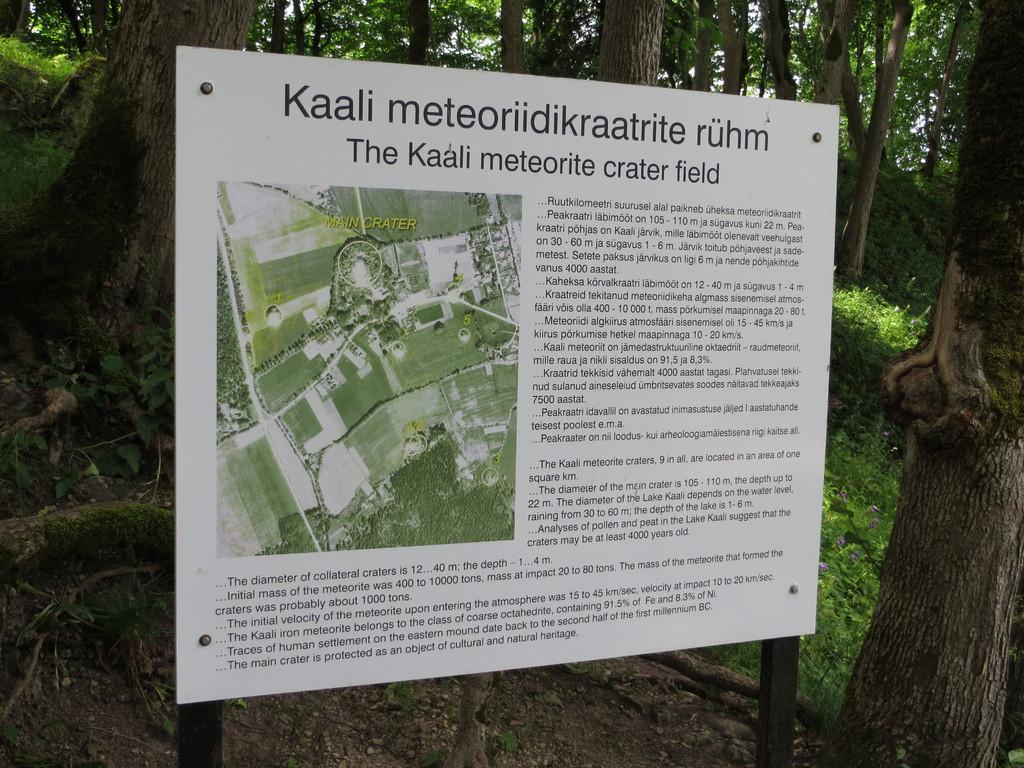Please provide a concise description of this image. In this image in the center there is one board, on the board there is text and an image of trees and some buildings. And in the background there are some trees, at the bottom there is sand and grass. 